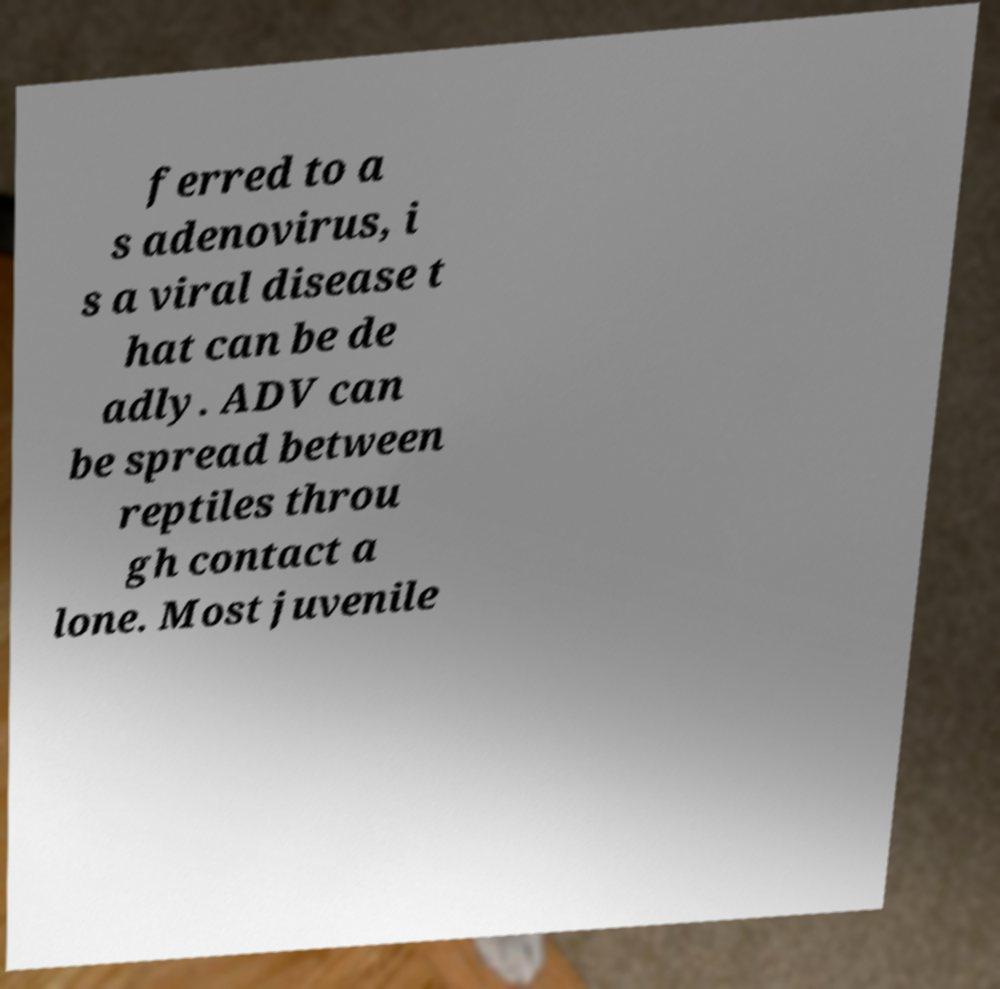I need the written content from this picture converted into text. Can you do that? ferred to a s adenovirus, i s a viral disease t hat can be de adly. ADV can be spread between reptiles throu gh contact a lone. Most juvenile 